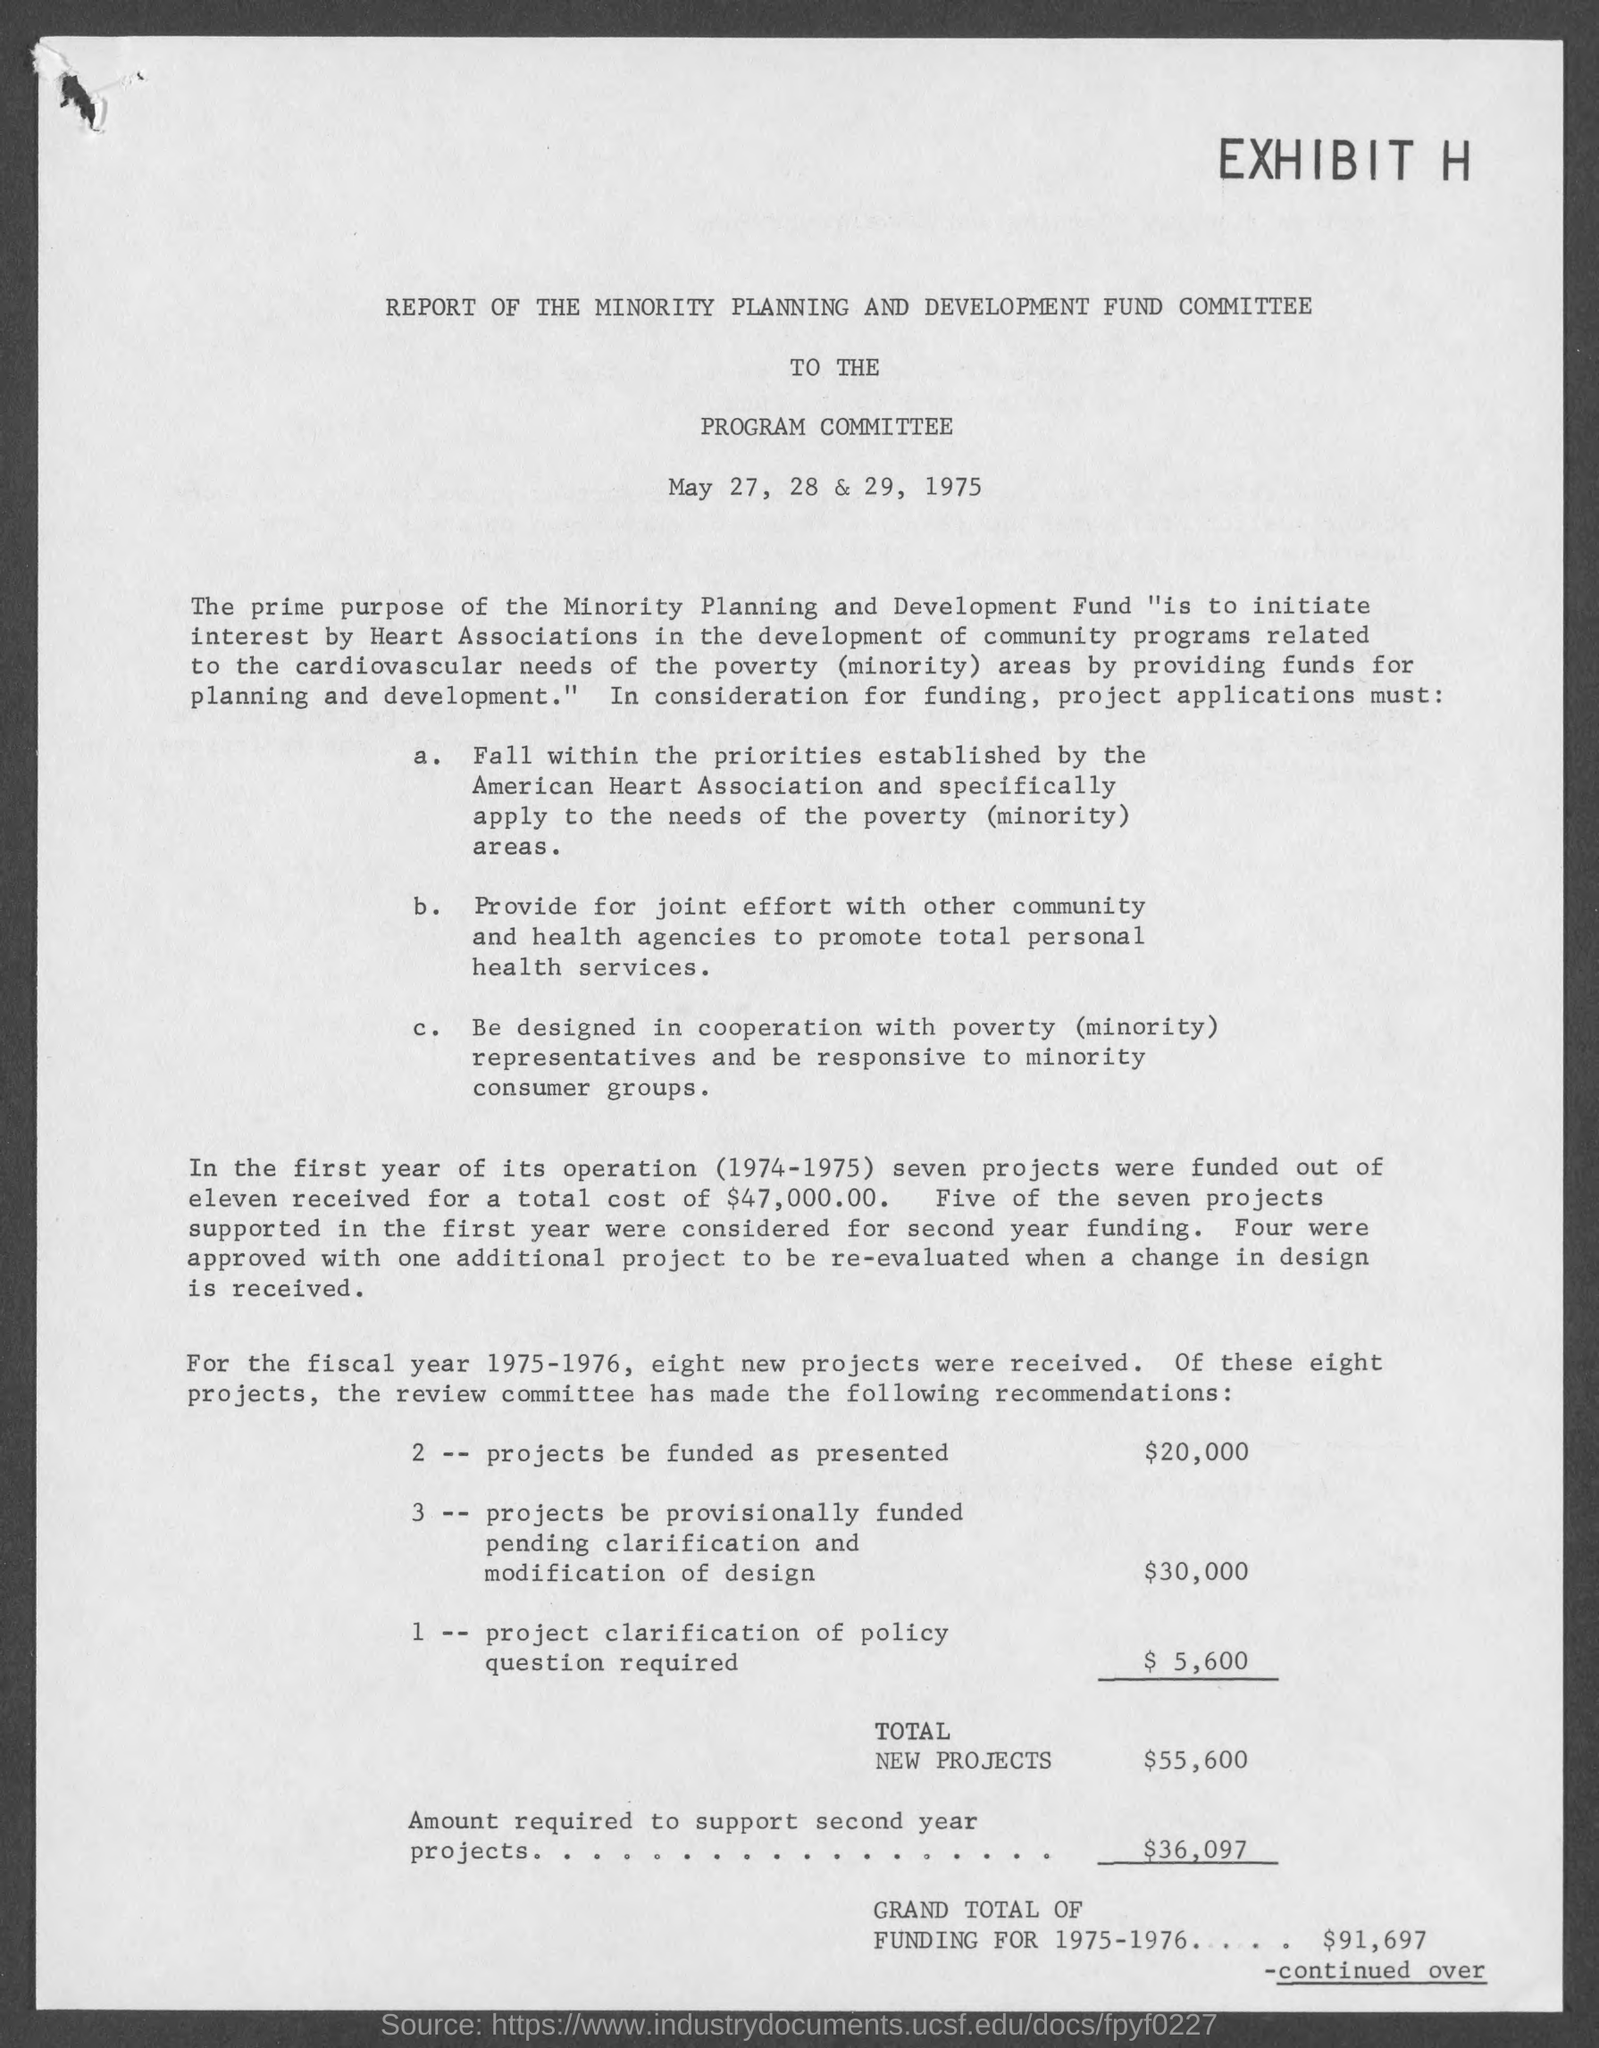To whom is this report to?
Give a very brief answer. Program Committee. What is amount for total new projects?
Make the answer very short. 55,600. What is the amount required to support second year projects?
Offer a very short reply. $36,097. What is grand total of funding for 1975-1976?
Offer a very short reply. $91,697. 